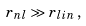Convert formula to latex. <formula><loc_0><loc_0><loc_500><loc_500>r _ { n l } \gg r _ { l i n } \, ,</formula> 